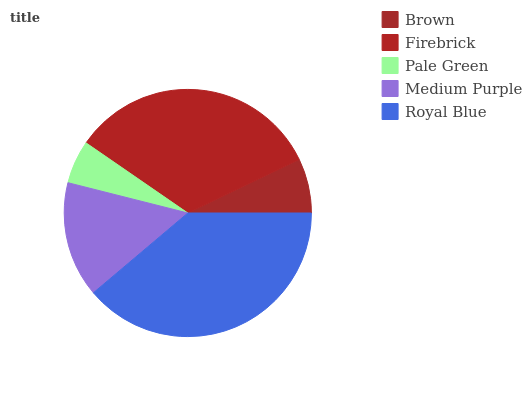Is Pale Green the minimum?
Answer yes or no. Yes. Is Royal Blue the maximum?
Answer yes or no. Yes. Is Firebrick the minimum?
Answer yes or no. No. Is Firebrick the maximum?
Answer yes or no. No. Is Firebrick greater than Brown?
Answer yes or no. Yes. Is Brown less than Firebrick?
Answer yes or no. Yes. Is Brown greater than Firebrick?
Answer yes or no. No. Is Firebrick less than Brown?
Answer yes or no. No. Is Medium Purple the high median?
Answer yes or no. Yes. Is Medium Purple the low median?
Answer yes or no. Yes. Is Royal Blue the high median?
Answer yes or no. No. Is Pale Green the low median?
Answer yes or no. No. 